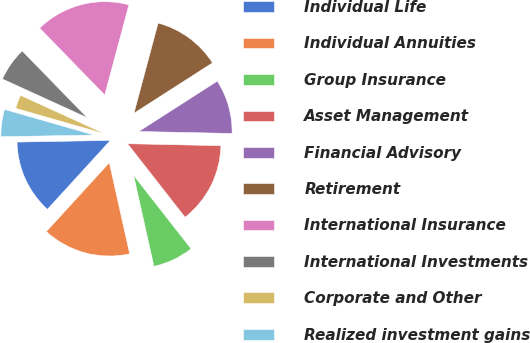Convert chart to OTSL. <chart><loc_0><loc_0><loc_500><loc_500><pie_chart><fcel>Individual Life<fcel>Individual Annuities<fcel>Group Insurance<fcel>Asset Management<fcel>Financial Advisory<fcel>Retirement<fcel>International Insurance<fcel>International Investments<fcel>Corporate and Other<fcel>Realized investment gains<nl><fcel>12.93%<fcel>15.28%<fcel>7.07%<fcel>14.1%<fcel>9.41%<fcel>11.76%<fcel>16.45%<fcel>5.9%<fcel>2.38%<fcel>4.72%<nl></chart> 